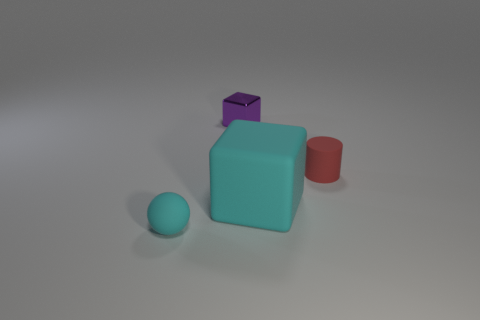What color is the rubber thing that is the same size as the cyan sphere?
Provide a short and direct response. Red. Does the small red rubber thing have the same shape as the cyan matte object that is right of the tiny sphere?
Offer a terse response. No. There is a block that is behind the small rubber thing that is on the right side of the cyan thing that is in front of the matte block; what is it made of?
Your answer should be very brief. Metal. What number of large things are either cyan matte spheres or purple metal blocks?
Your response must be concise. 0. What number of other objects are the same size as the cyan block?
Your answer should be very brief. 0. There is a cyan object right of the cyan matte sphere; does it have the same shape as the tiny cyan matte thing?
Keep it short and to the point. No. The other object that is the same shape as the large object is what color?
Keep it short and to the point. Purple. Is there anything else that is the same shape as the red rubber thing?
Offer a very short reply. No. Are there an equal number of rubber cubes that are left of the big cyan rubber block and big cubes?
Provide a short and direct response. No. What number of tiny objects are both behind the small red cylinder and left of the metal block?
Your answer should be compact. 0. 